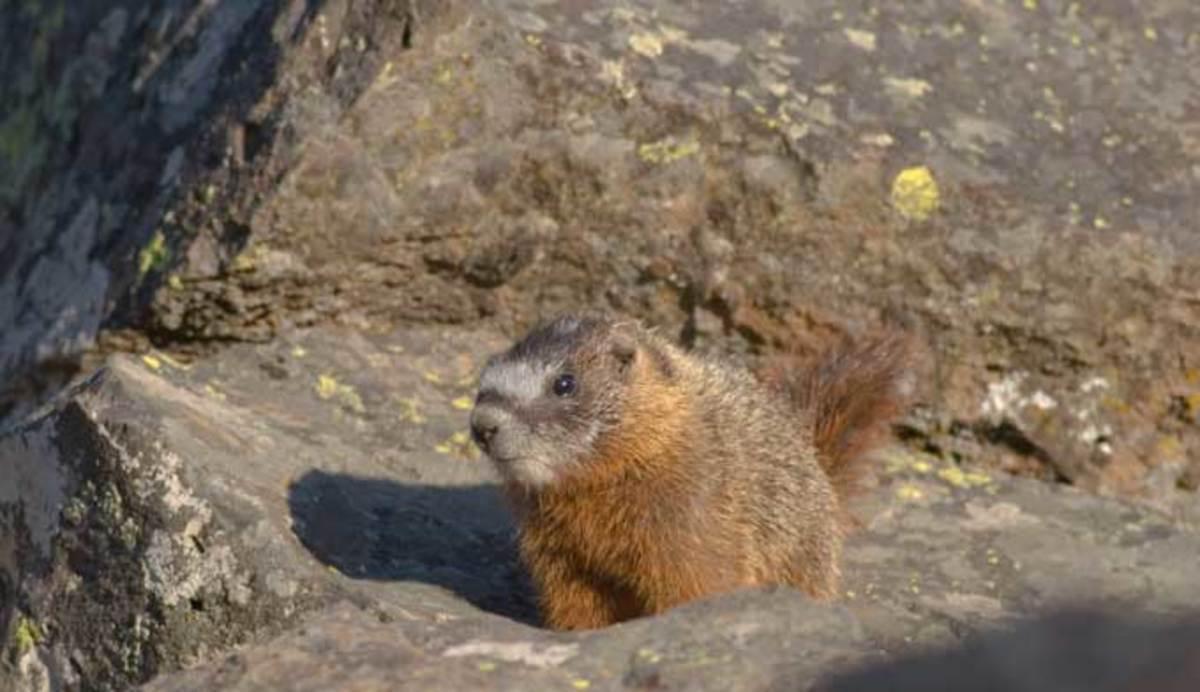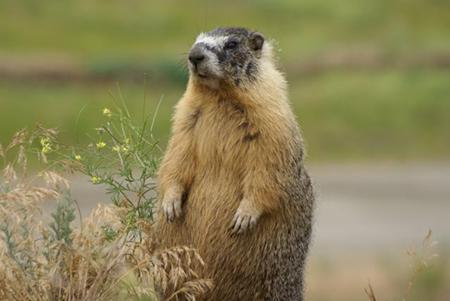The first image is the image on the left, the second image is the image on the right. Evaluate the accuracy of this statement regarding the images: "Each image contains a single marmot, and the right image features a marmot standing and facing leftward.". Is it true? Answer yes or no. Yes. The first image is the image on the left, the second image is the image on the right. Given the left and right images, does the statement "There are exactly 2 marmots and one of them is standing on its hind legs." hold true? Answer yes or no. Yes. 